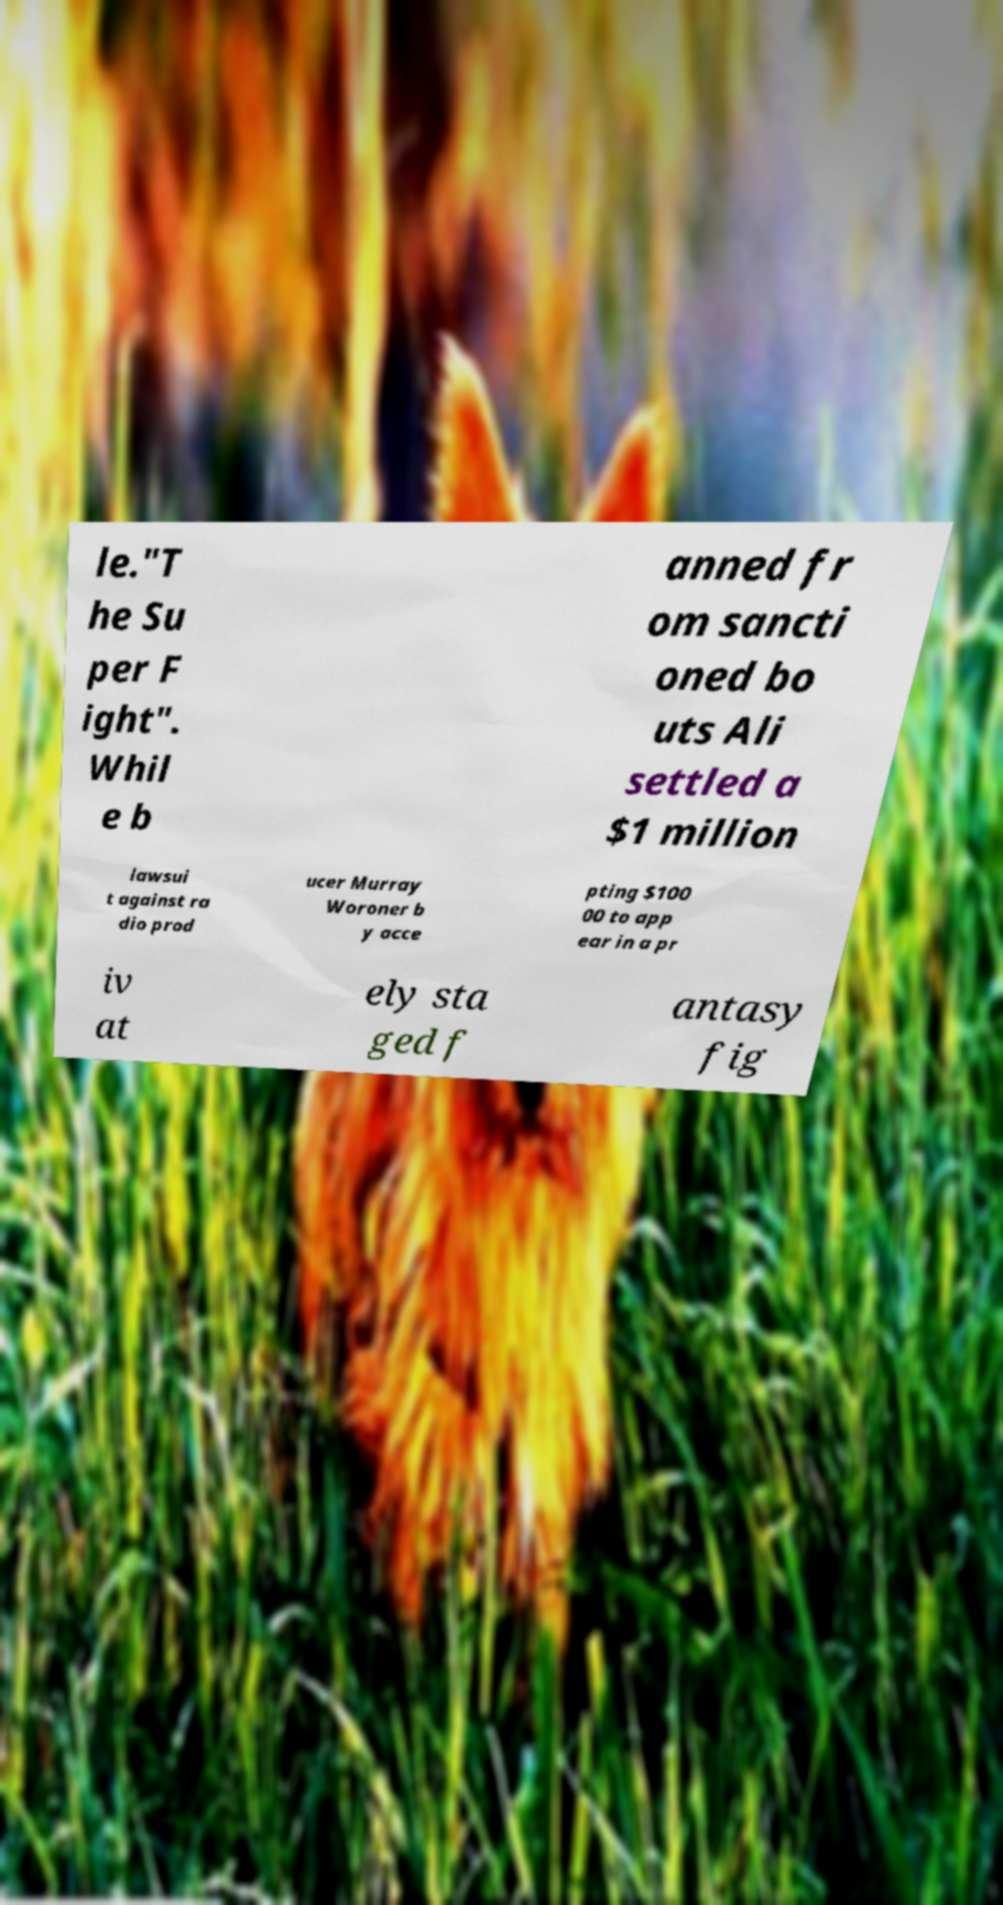There's text embedded in this image that I need extracted. Can you transcribe it verbatim? le."T he Su per F ight". Whil e b anned fr om sancti oned bo uts Ali settled a $1 million lawsui t against ra dio prod ucer Murray Woroner b y acce pting $100 00 to app ear in a pr iv at ely sta ged f antasy fig 